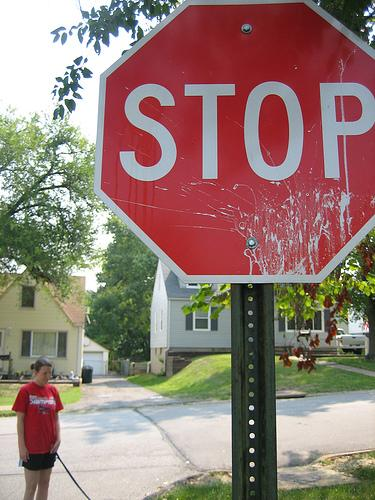As an advertisement for a product, create a short tagline that highlights the waste container in the driveway. "Keep your driveway clean and organized with our sleek, resilient, and easy-to-use waste container!" Imagine you are a real estate agent using this image for advertisement. Describe the house and its surroundings in a few words. Charming yellow house with red roof, nestled in a peaceful neighborhood, surrounded by lush trees and a well-maintained lawn, close to a stop sign for safety. What is a person wearing in the image, and what is she doing? The person is a woman wearing a red shirt, black and white shorts, and holding a leash in her left hand. She is standing near a stop sign on a street corner. Based on the visual entailment task, what conclusion can you make about the relationship between the lady and the stop sign in the image? The lady is standing near the stop sign, possibly waiting to cross the street or walking her pet with the leash in her hand. 